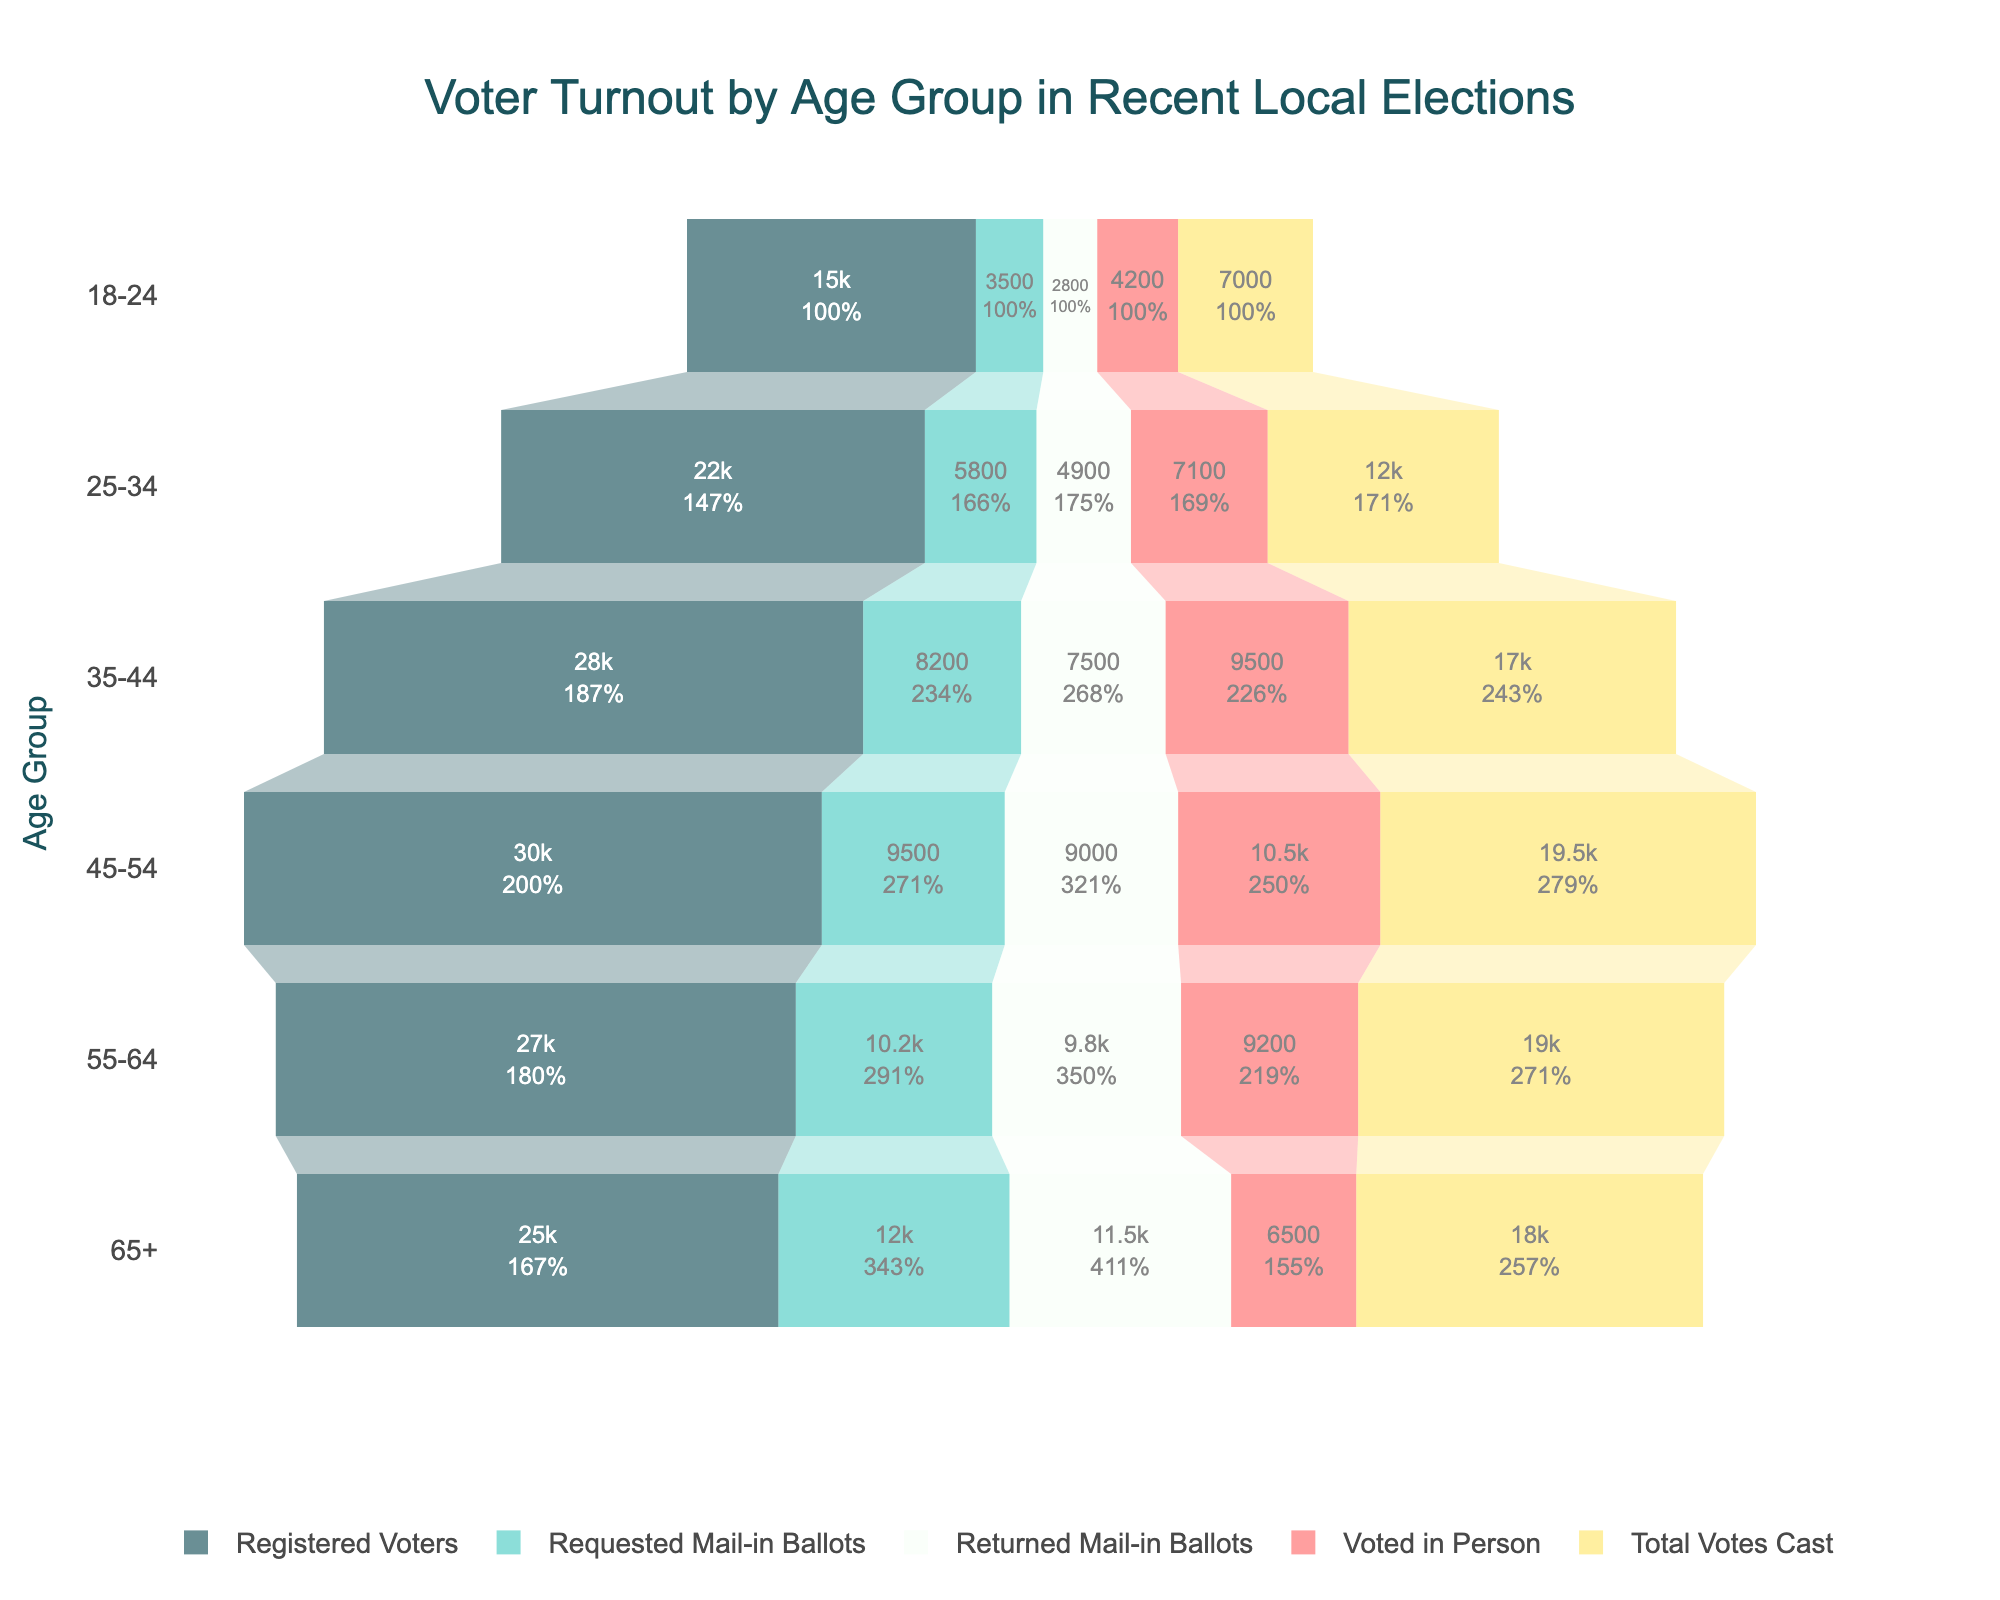Which age group has the highest number of registered voters? To determine the age group with the highest number of registered voters, we look for the highest value under the "Registered Voters" column. The age group 45-54 has 30,000 registered voters, the highest among all groups.
Answer: 45-54 How many total ballots were requested by all age groups combined? To calculate the total number of requested mail-in ballots, sum the values in the "Requested Mail-in Ballots" column: 3500 + 5800 + 8200 + 9500 + 10200 + 12000 = 49200.
Answer: 49200 Which age group has the lowest turnout in terms of total votes cast? To determine the age group with the lowest total votes cast, we look for the lowest value in the "Total Votes Cast" column. The age group 18-24 has the lowest total votes cast, with 7,000.
Answer: 18-24 What percentage of registered voters in the 65+ age group voted in person? First, find the number of people who voted in person in the 65+ age group, which is 6,500. Then, divide this by the total number of registered voters in that age group (25,000), and multiply by 100 to get the percentage. (6500 / 25000) * 100 = 26%.
Answer: 26% How does the number of returned mail-in ballots for the 55-64 age group compare to the 45-54 age group? Check the values: The 55-64 age group has 9,800 returned mail-in ballots, and the 45-54 age group has 9,000. The 55-64 age group has 800 more returned mail-in ballots than the 45-54 age group.
Answer: 800 more Among the age groups 25-34 and 35-44, which one had a higher number of mail-in ballots returned as a percentage of requested mail-in ballots? For the 25-34 age group, 4,900 returned mail-in ballots out of 5,800 requested: (4900 / 5800) * 100 ≈ 84.48%. For the 35-44 age group, 7,500 returned mail-in ballots out of 8,200 requested: (7500 / 8200) * 100 ≈ 91.46%. The 35-44 age group had a higher return rate.
Answer: 35-44 What is the average number of total votes cast across all age groups? Sum the total votes cast: 7,000 + 12,000 + 17,000 + 19,500 + 19,000 + 18,000 = 92,500. Divide by the number of age groups (6): 92,500 / 6 ≈ 15,417.
Answer: 15,417 